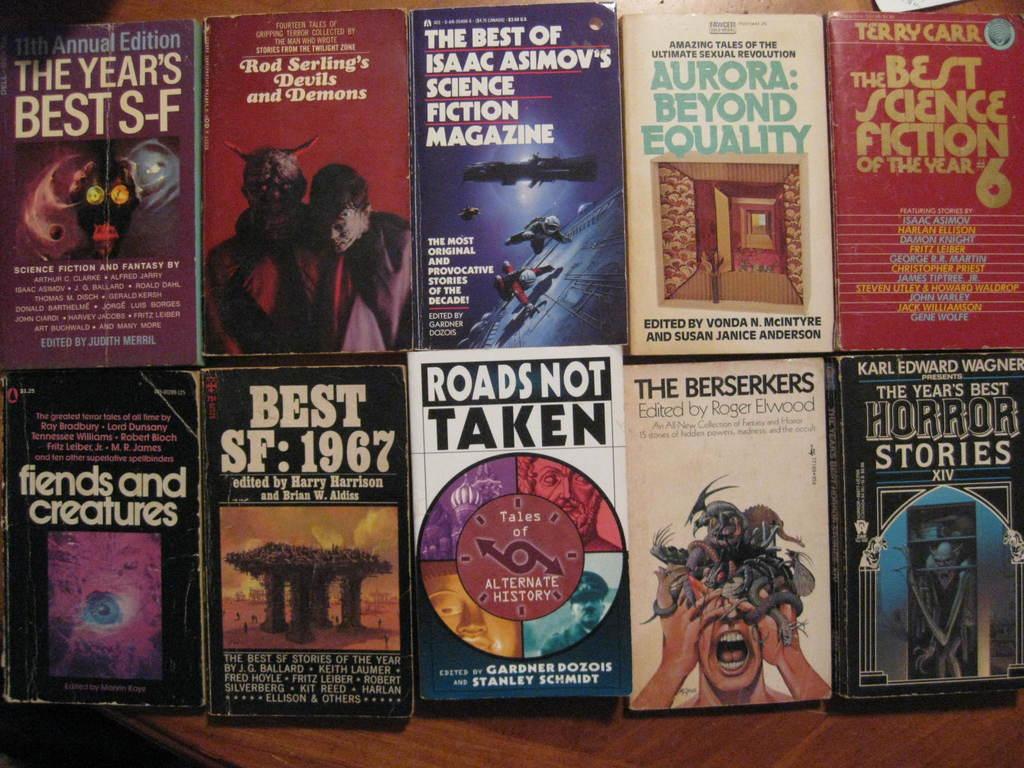Who edited the book with a man who has snakes coming out of his head?
Provide a short and direct response. Roger elwood. 